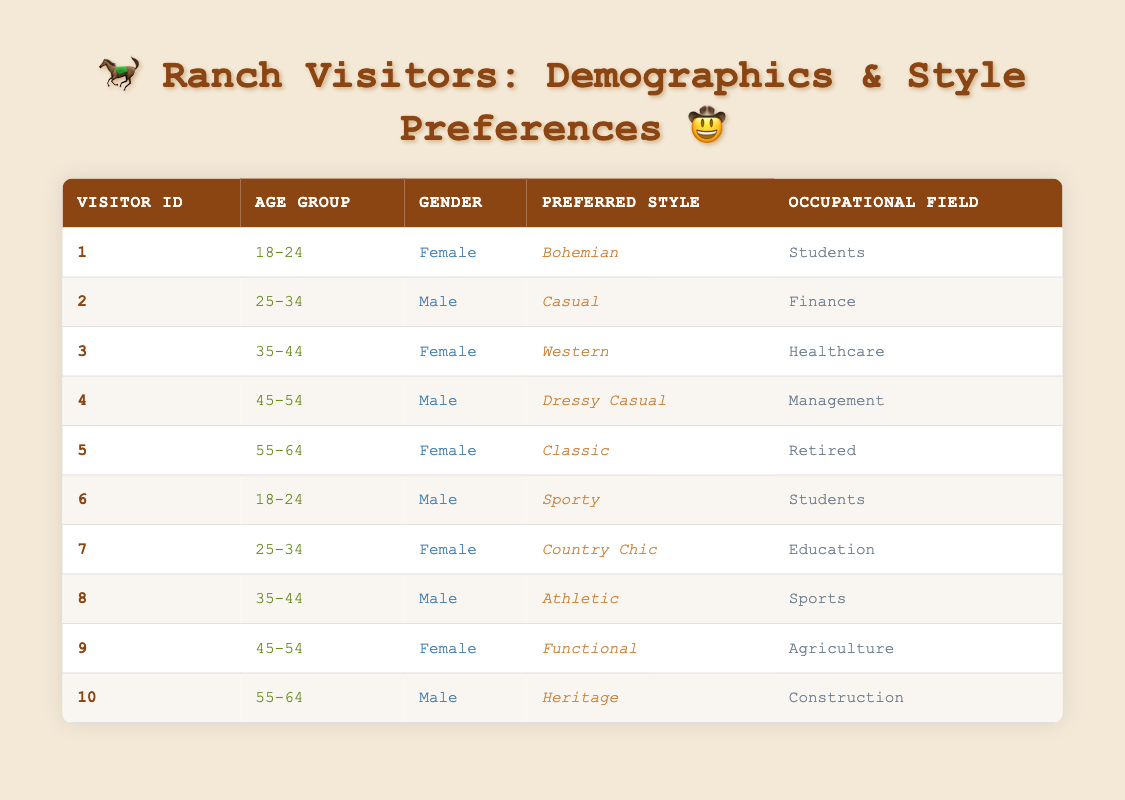What is the preferred style of the youngest visitor? The youngest visitors are in the age group of 18-24. There are two visitors in this group: Visitor ID 1 prefers "Bohemian" and Visitor ID 6 prefers "Sporty". Since both are from the same age group, I can say the preferred styles for the youngest visitors are "Bohemian" and "Sporty".
Answer: Bohemian and Sporty How many male visitors prefer a Western style? Looking through the table, there is only one female visitor (Visitor ID 3) who prefers "Western". Since the question specifically asks for male visitors, the answer is 0.
Answer: 0 What is the most common preferred style among visitors aged 45-54? In the table, there are two visitors in the 45-54 age group (Visitor ID 4 and Visitor ID 9). Visitor ID 4 prefers "Dressy Casual" while Visitor ID 9 prefers "Functional". Both styles are different, indicating no clear most common style in this age group.
Answer: No common style Are there any retired visitors who prefer a Classic style? Visitor ID 5 is the only retired visitor and she prefers "Classic" style according to the table. Therefore, the answer to this question is yes.
Answer: Yes What percentage of visitors aged 35-44 prefer a sporty style? There are two visitors in the 35-44 age group (Visitor ID 3 and Visitor ID 8) and neither of them prefers "Sporty". Therefore, the percentage of visitors aged 35-44 who prefer a sporty style is calculated as (0/2) * 100 = 0%.
Answer: 0% How many female visitors prefer styles that could be classified as "casual"? From examining the table, there are three styles that can be considered casual: "Casual" (Visitor ID 2), "Dressy Casual" (Visitor ID 4), "Country Chic" (Visitor ID 7), and "Classic" (Visitor ID 5). Only Visitor ID 7 is female, so there is 1 female casual style preference.
Answer: 1 Which occupational field has the most diverse style preferences among visitors? Looking at the table, "Education", "Students", and "Healthcare" have multiple representatives. The "Students" field has 2 visitors with "Bohemian" and "Sporty" styles, while "Education" has 1 visitor with "Country Chic". We identify that "Students" presents 2 diverse styles.
Answer: Students What is the most frequent age group among visitors who prefer Western style? In the table, only Visitor ID 3 belongs to the "35-44" age group and prefers "Western". Since there are no other visitors in that age group who like Western style, the answer is just the age group of Visitor ID 3.
Answer: 35-44 